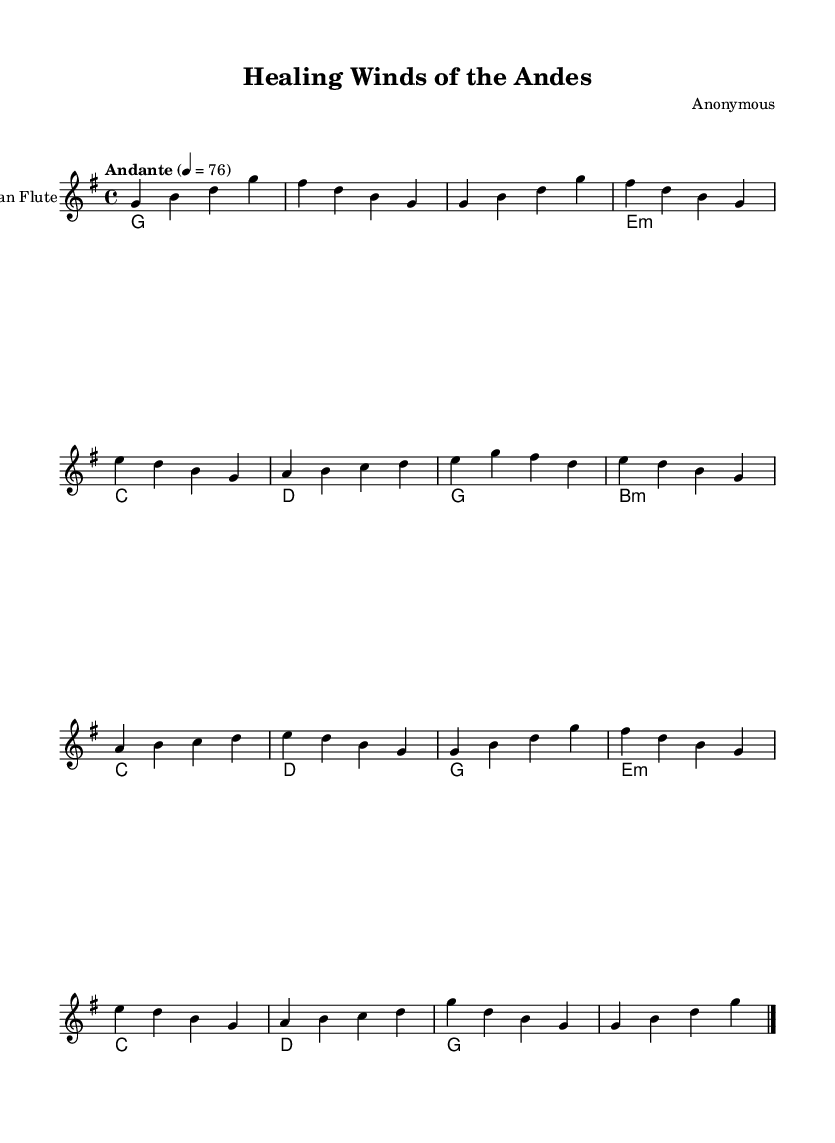What is the key signature of this music? The key signature is G major, which has one sharp (F#).
Answer: G major What is the time signature of this piece? The time signature is 4/4, meaning there are four beats in each measure.
Answer: 4/4 What is the tempo marking indicated for this music? The tempo marking is "Andante," which suggests a moderate pace.
Answer: Andante How many measures are in section A? Section A consists of four measures, as indicated by counting the measures labeled with musical content.
Answer: 4 What is the first note played by the pan flute? The first note played by the pan flute is G, as shown at the beginning of the score.
Answer: G What chord is played in the first measure? The chord in the first measure is G major, which is indicated under the pan flute staff.
Answer: G What is the overall mood described by the style of this music? The overall mood is uplifting, described by the characteristics of Andean pan flute music often associated with healing and meditation.
Answer: Uplifting 